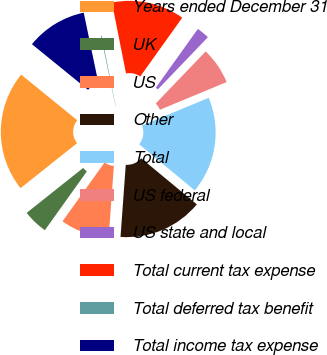Convert chart to OTSL. <chart><loc_0><loc_0><loc_500><loc_500><pie_chart><fcel>Years ended December 31<fcel>UK<fcel>US<fcel>Other<fcel>Total<fcel>US federal<fcel>US state and local<fcel>Total current tax expense<fcel>Total deferred tax benefit<fcel>Total income tax expense<nl><fcel>21.56%<fcel>4.43%<fcel>8.72%<fcel>15.14%<fcel>17.28%<fcel>6.57%<fcel>2.29%<fcel>13.0%<fcel>0.15%<fcel>10.86%<nl></chart> 